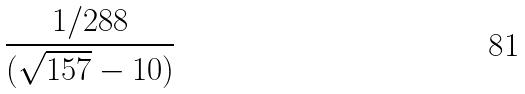<formula> <loc_0><loc_0><loc_500><loc_500>\frac { 1 / 2 8 8 } { ( \sqrt { 1 5 7 } - 1 0 ) }</formula> 